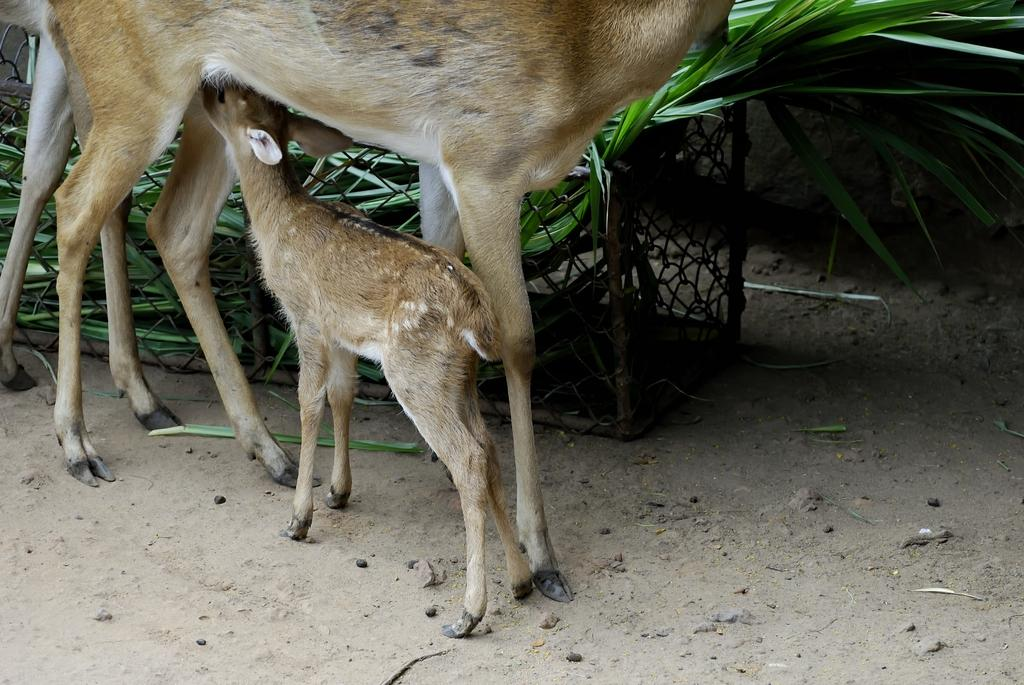How many animals are present in the image? There are two animals in the image. What colors can be seen on the animals? The animals are in cream and brown color. What can be seen in the background of the image? There is a railing and green leaves in the background of the image. What type of plantation can be seen in the image? There is no plantation present in the image; it features two animals and a background with a railing and green leaves. Can you tell me how the animals are using a wrench in the image? There is no wrench present in the image; the animals are simply depicted in their natural state. 